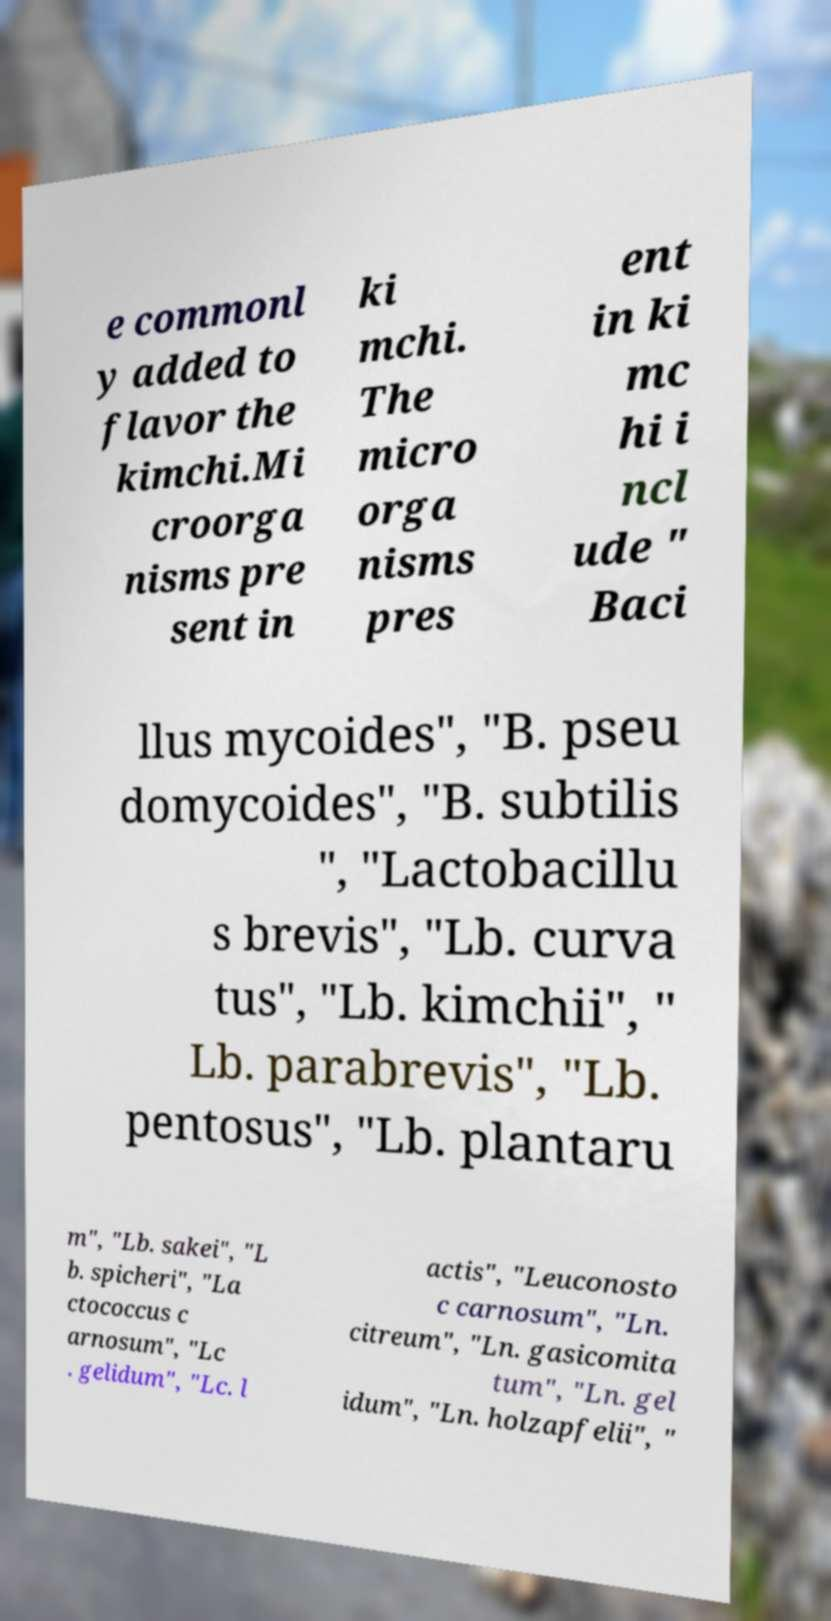Can you accurately transcribe the text from the provided image for me? e commonl y added to flavor the kimchi.Mi croorga nisms pre sent in ki mchi. The micro orga nisms pres ent in ki mc hi i ncl ude " Baci llus mycoides", "B. pseu domycoides", "B. subtilis ", "Lactobacillu s brevis", "Lb. curva tus", "Lb. kimchii", " Lb. parabrevis", "Lb. pentosus", "Lb. plantaru m", "Lb. sakei", "L b. spicheri", "La ctococcus c arnosum", "Lc . gelidum", "Lc. l actis", "Leuconosto c carnosum", "Ln. citreum", "Ln. gasicomita tum", "Ln. gel idum", "Ln. holzapfelii", " 